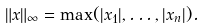Convert formula to latex. <formula><loc_0><loc_0><loc_500><loc_500>\| x \| _ { \infty } = \max ( | x _ { 1 } | , \dots , | x _ { n } | ) .</formula> 